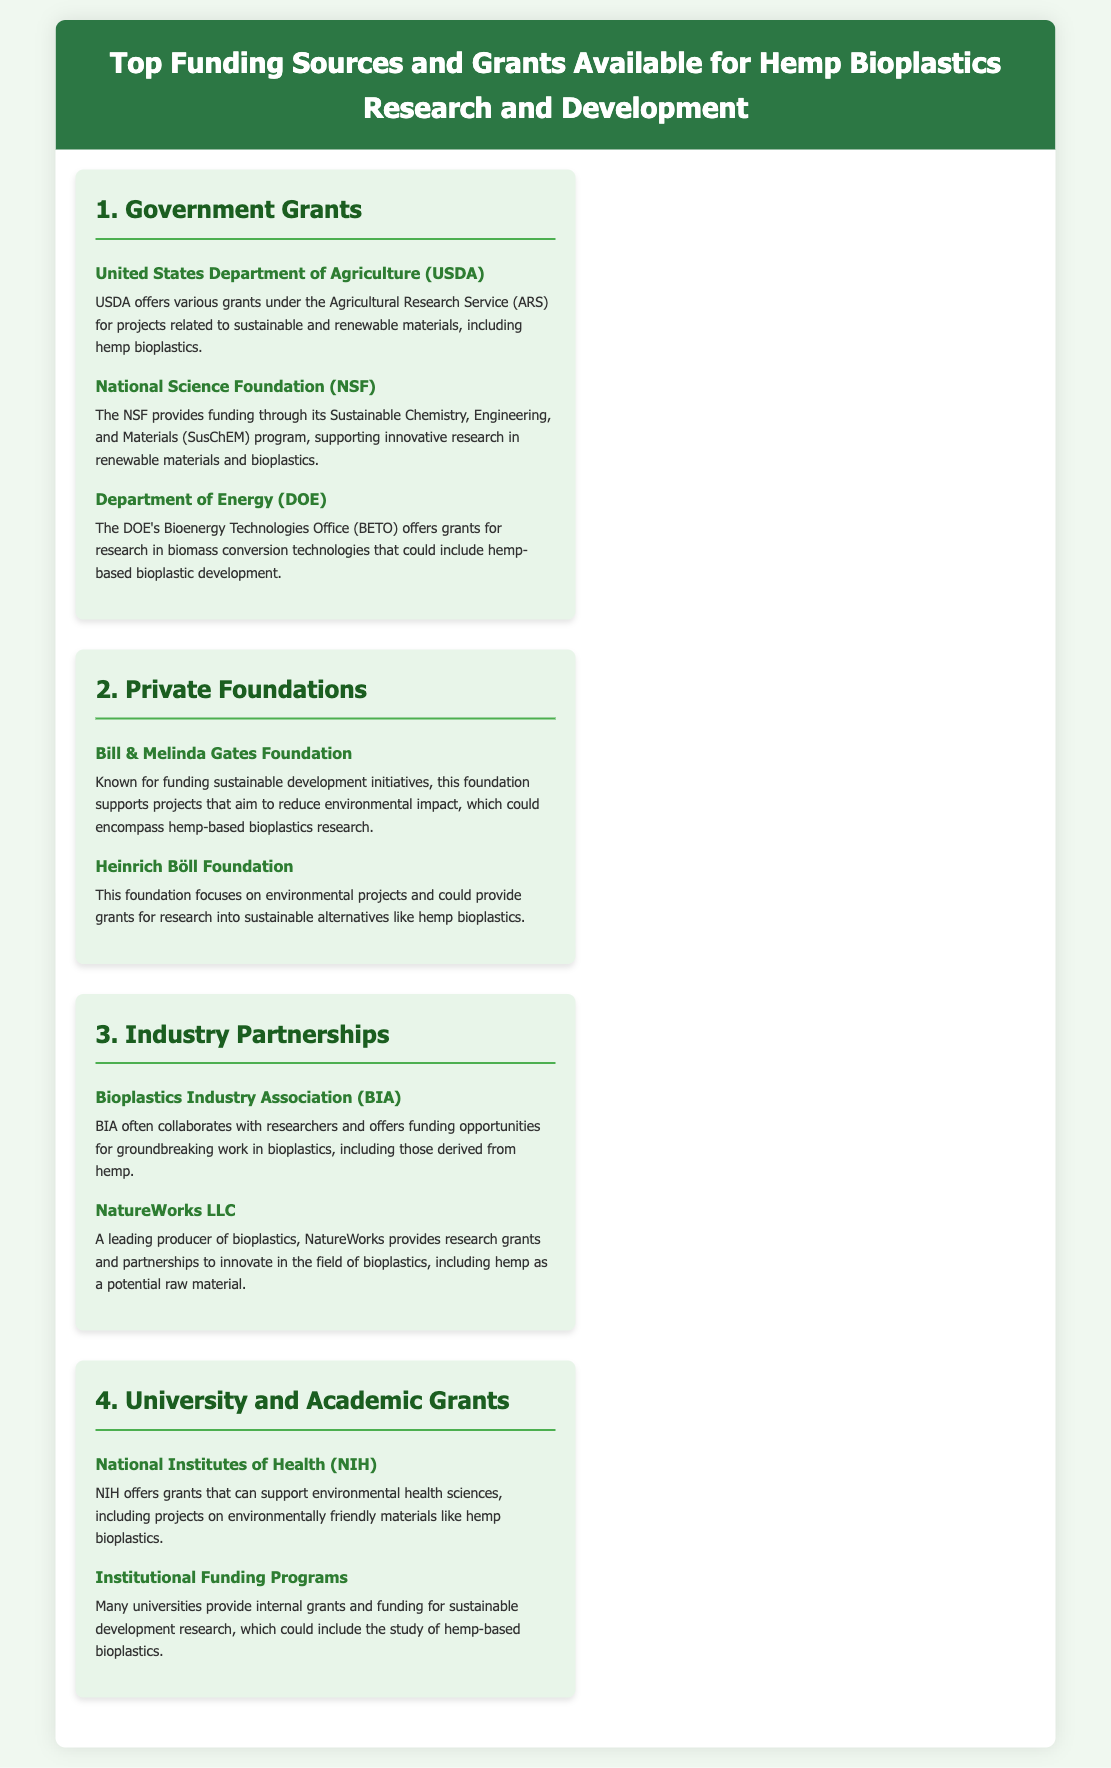What is one of the government grants available for hemp bioplastics research? The document lists various government grants, including those from the United States Department of Agriculture (USDA) for projects related to sustainable materials.
Answer: United States Department of Agriculture (USDA) Which private foundation focuses on environmental projects? The Heinrich Böll Foundation is mentioned in the document as offering grants for research into sustainable alternatives like hemp bioplastics.
Answer: Heinrich Böll Foundation What industry partnership collaborates with researchers on bioplastics? The Bioplastics Industry Association (BIA) is identified in the document as an organization that offers funding opportunities for bioplastics research.
Answer: Bioplastics Industry Association (BIA) How many government grants are listed for hemp bioplastics research? The document mentions three specific government grants under the section titled "Government Grants."
Answer: Three Which organization provides research grants in the field of bioplastics? NatureWorks LLC is mentioned in the document as a leading producer of bioplastics that provides research grants.
Answer: NatureWorks LLC What type of funding does the National Institutes of Health (NIH) offer? The NIH offers grants that can support environmental health sciences and projects related to environmentally friendly materials like hemp bioplastics.
Answer: Grants Which section details funding from private foundations? The section named "Private Foundations" in the document contains information on funding sources from foundations.
Answer: Private Foundations What kind of projects does the USDA support? The USDA supports projects related to sustainable and renewable materials, including hemp bioplastics.
Answer: Sustainable and renewable materials 